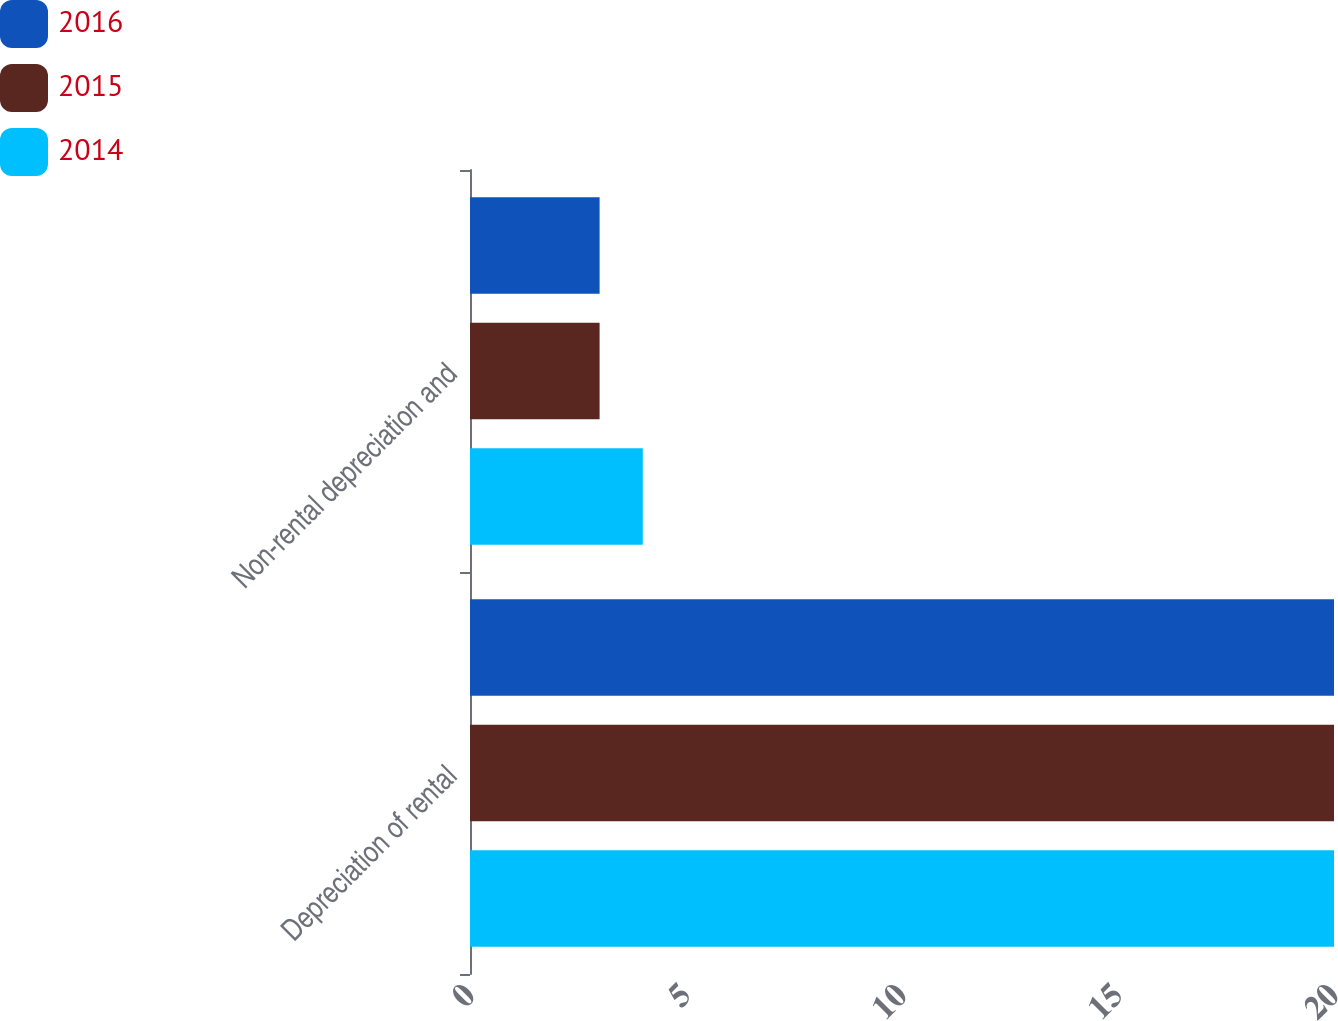<chart> <loc_0><loc_0><loc_500><loc_500><stacked_bar_chart><ecel><fcel>Depreciation of rental<fcel>Non-rental depreciation and<nl><fcel>2016<fcel>20<fcel>3<nl><fcel>2015<fcel>20<fcel>3<nl><fcel>2014<fcel>20<fcel>4<nl></chart> 